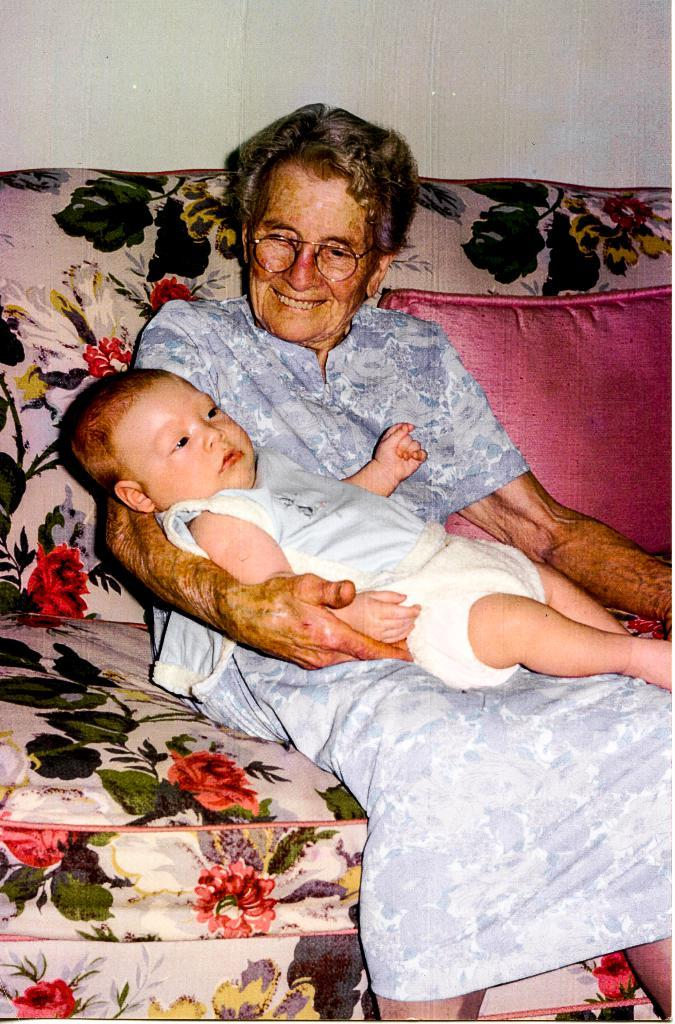What is the main subject of the image? There is a person in the image. What is the person wearing? The person is wearing clothes. What is the person doing in the image? The person is sitting on a sofa and holding a baby with her hand. What can be seen at the top of the image? There is a wall visible at the top of the image. How many pages are visible in the image? There are no pages present in the image. What type of bead is being used for adjustment in the image? There is no bead or adjustment being made in the image. 